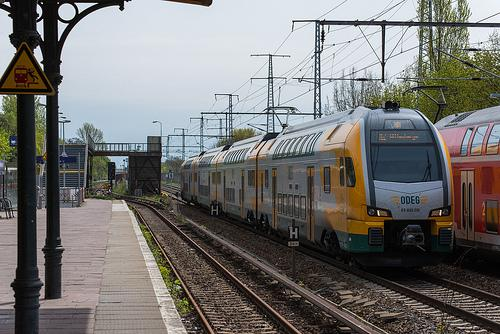Question: what are trains on?
Choices:
A. Roads.
B. Bridges.
C. Train tracks.
D. Sidewalks.
Answer with the letter. Answer: C Question: what shape is the yellow sign?
Choices:
A. Square.
B. Rectangle.
C. Circle.
D. Triangle.
Answer with the letter. Answer: D Question: what letters are on the front on the yellow train?
Choices:
A. Dego.
B. Egod.
C. Gode.
D. ODEG.
Answer with the letter. Answer: D Question: where is this picture taken?
Choices:
A. The train station.
B. The subway.
C. The restaurant.
D. The transit.
Answer with the letter. Answer: A Question: how many people are in the picture?
Choices:
A. One.
B. Zero.
C. Two.
D. Three.
Answer with the letter. Answer: B 